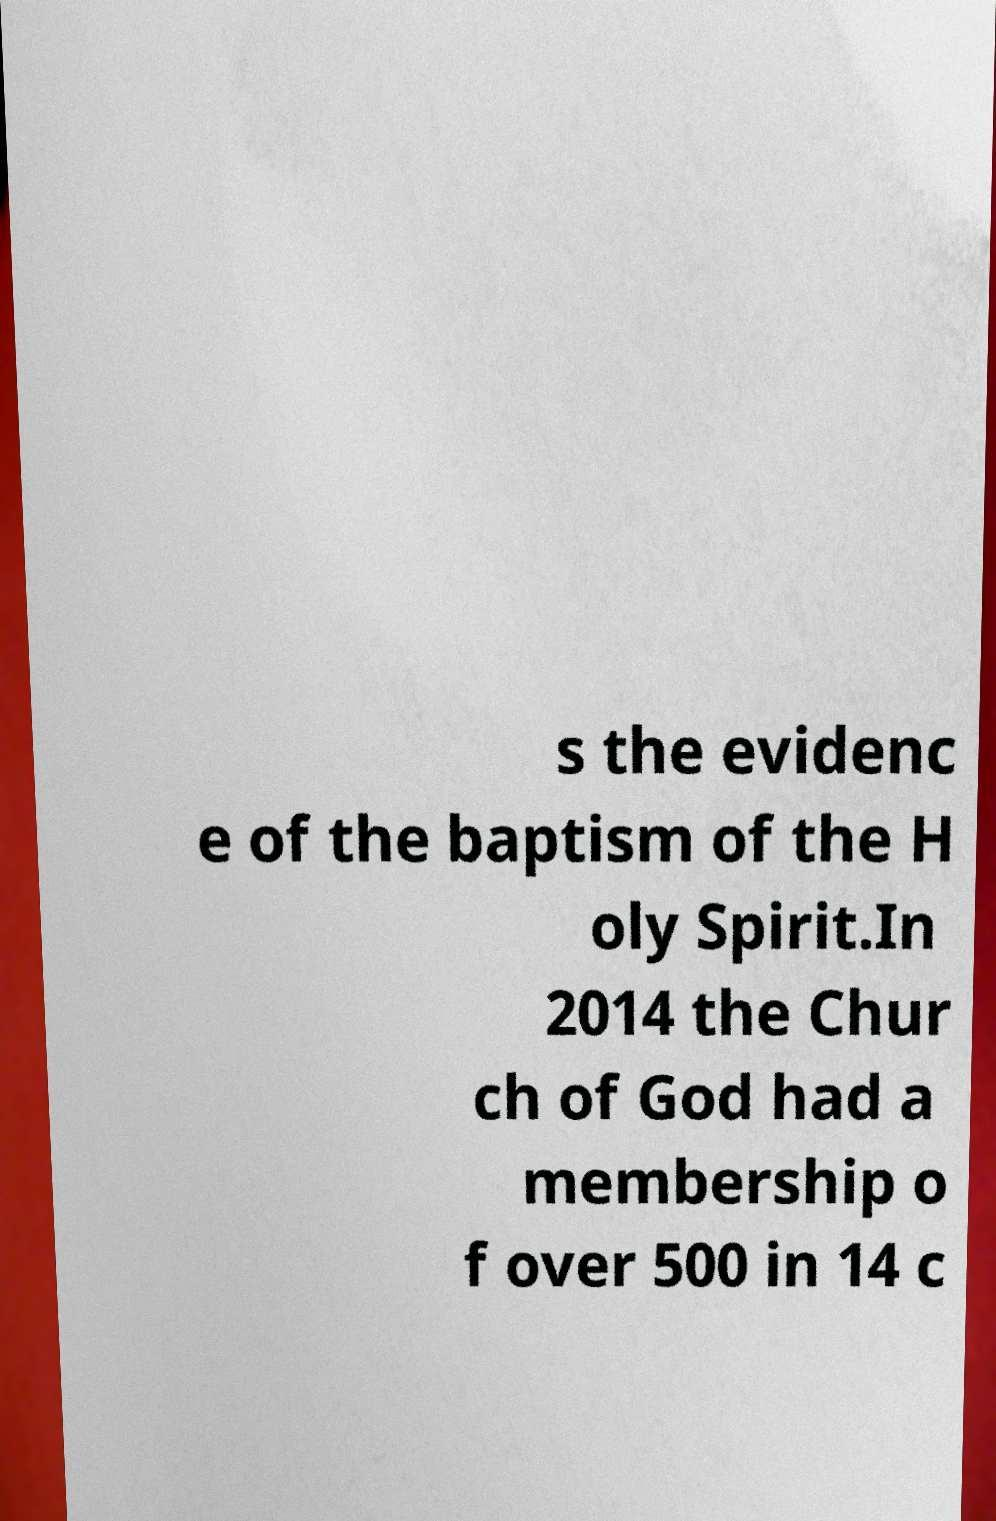Can you read and provide the text displayed in the image?This photo seems to have some interesting text. Can you extract and type it out for me? s the evidenc e of the baptism of the H oly Spirit.In 2014 the Chur ch of God had a membership o f over 500 in 14 c 